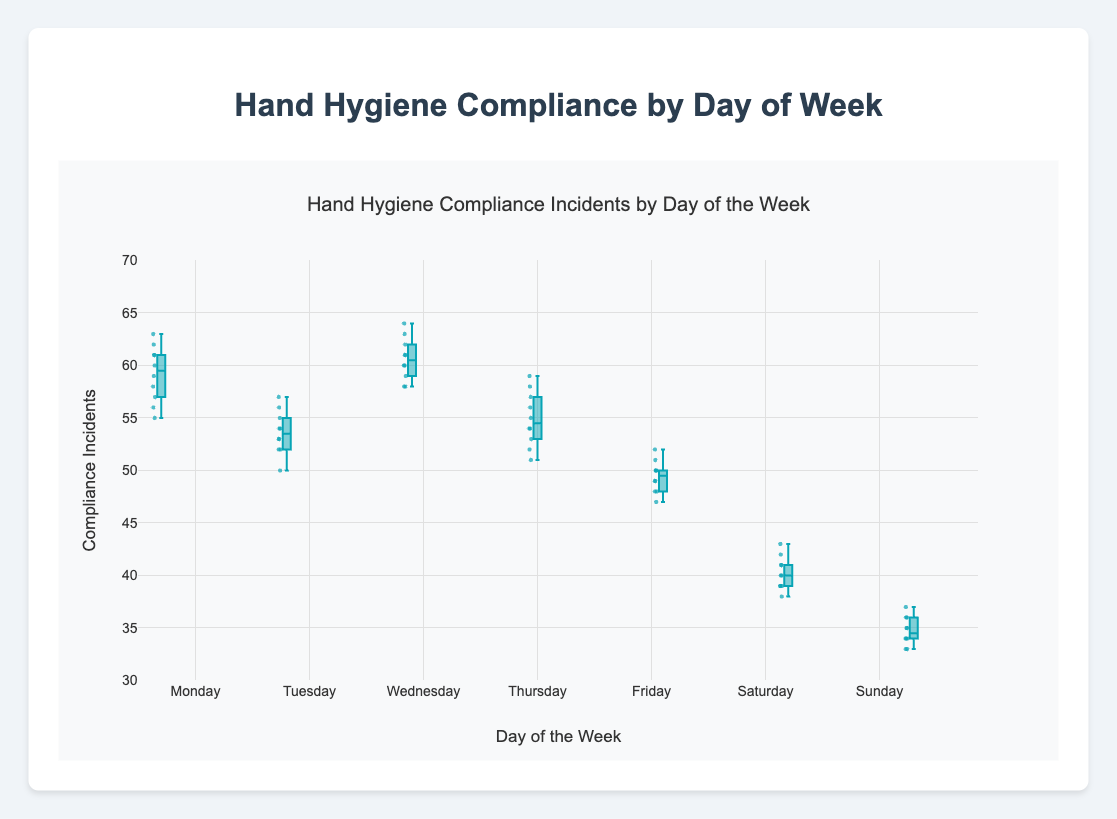What is the median compliance incident frequency on Saturday? The median is the middle value in the sorted list of numbers. For Saturday, the values sorted are [38, 39, 39, 39, 40, 40, 41, 41, 42, 43]. There are 10 values, so the median will be the average of the 5th and 6th values: (40 + 40) / 2
Answer: 40 Which day shows the highest median compliance incident frequency? To determine this, we look at the median line within each box plot. Wednesday has the highest median incidence value.
Answer: Wednesday Which day has the lowest range of compliance incidents? The range can be determined by looking at the length of the box and the whiskers. Sunday has the shortest box and whisker length, indicating the lowest range.
Answer: Sunday Which day has the most variability in compliance incidents? The variability can be assessed by the interquartile range (IQR), which is the height of the box. Wednesday has the tallest box, suggesting the highest variability.
Answer: Wednesday Compare the compliance incident frequency on Monday and Friday; which day has a higher maximum? For this, we compare the top whiskers of both days. Monday reaches 63, whereas Friday reaches 52, so Monday has a higher maximum.
Answer: Monday How does the median compliance incident frequency on Friday compare to Tuesday? We check the median lines within the boxes. Friday’s median is 50, whereas Tuesday's median is approximately 53. Therefore, Tuesday's median is higher.
Answer: Tuesday What is the interquartile range (IQR) for Thursday? The IQR is calculated as the difference between the third quartile (Q3) and the first quartile (Q1). For Thursday: Q3 ≈ 58, Q1 ≈ 53, thus IQR = 58 - 53
Answer: 5 Are there any outliers in the data? If so, which days have them? Outliers are shown as points outside the whiskers. Thursday and Wednesday have visible outliers.
Answer: Thursday and Wednesday Which day shows the lowest minimum compliance incident frequency? By comparing the bottom whiskers, Sunday has the lowest minimum reaching 33.
Answer: Sunday Are there any significant differences between weekend compliance (Saturday and Sunday) and weekday compliance (Monday to Friday)? By looking at the boxes and medians, weekend compliance is significantly lower compared to weekdays. Weekdays show higher medians and more tightly grouped incidents.
Answer: Yes, weekends are significantly lower 